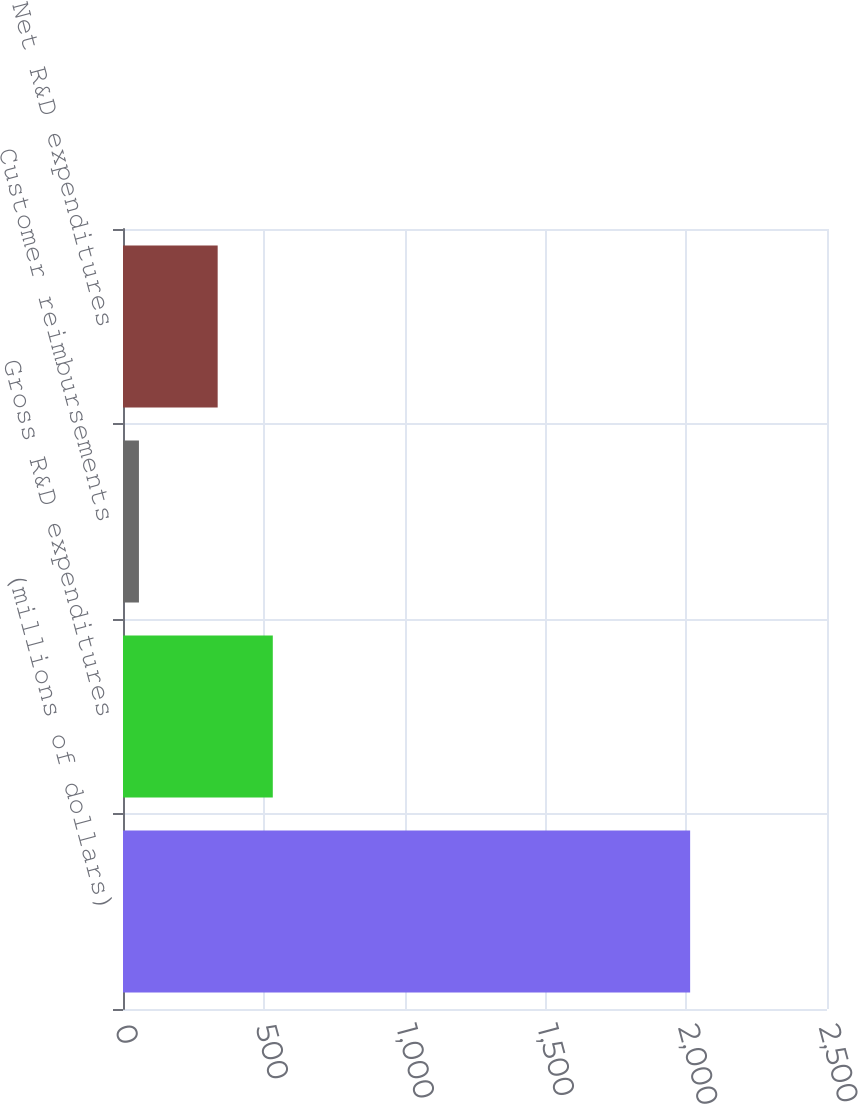Convert chart. <chart><loc_0><loc_0><loc_500><loc_500><bar_chart><fcel>(millions of dollars)<fcel>Gross R&D expenditures<fcel>Customer reimbursements<fcel>Net R&D expenditures<nl><fcel>2014<fcel>531.94<fcel>56.6<fcel>336.2<nl></chart> 